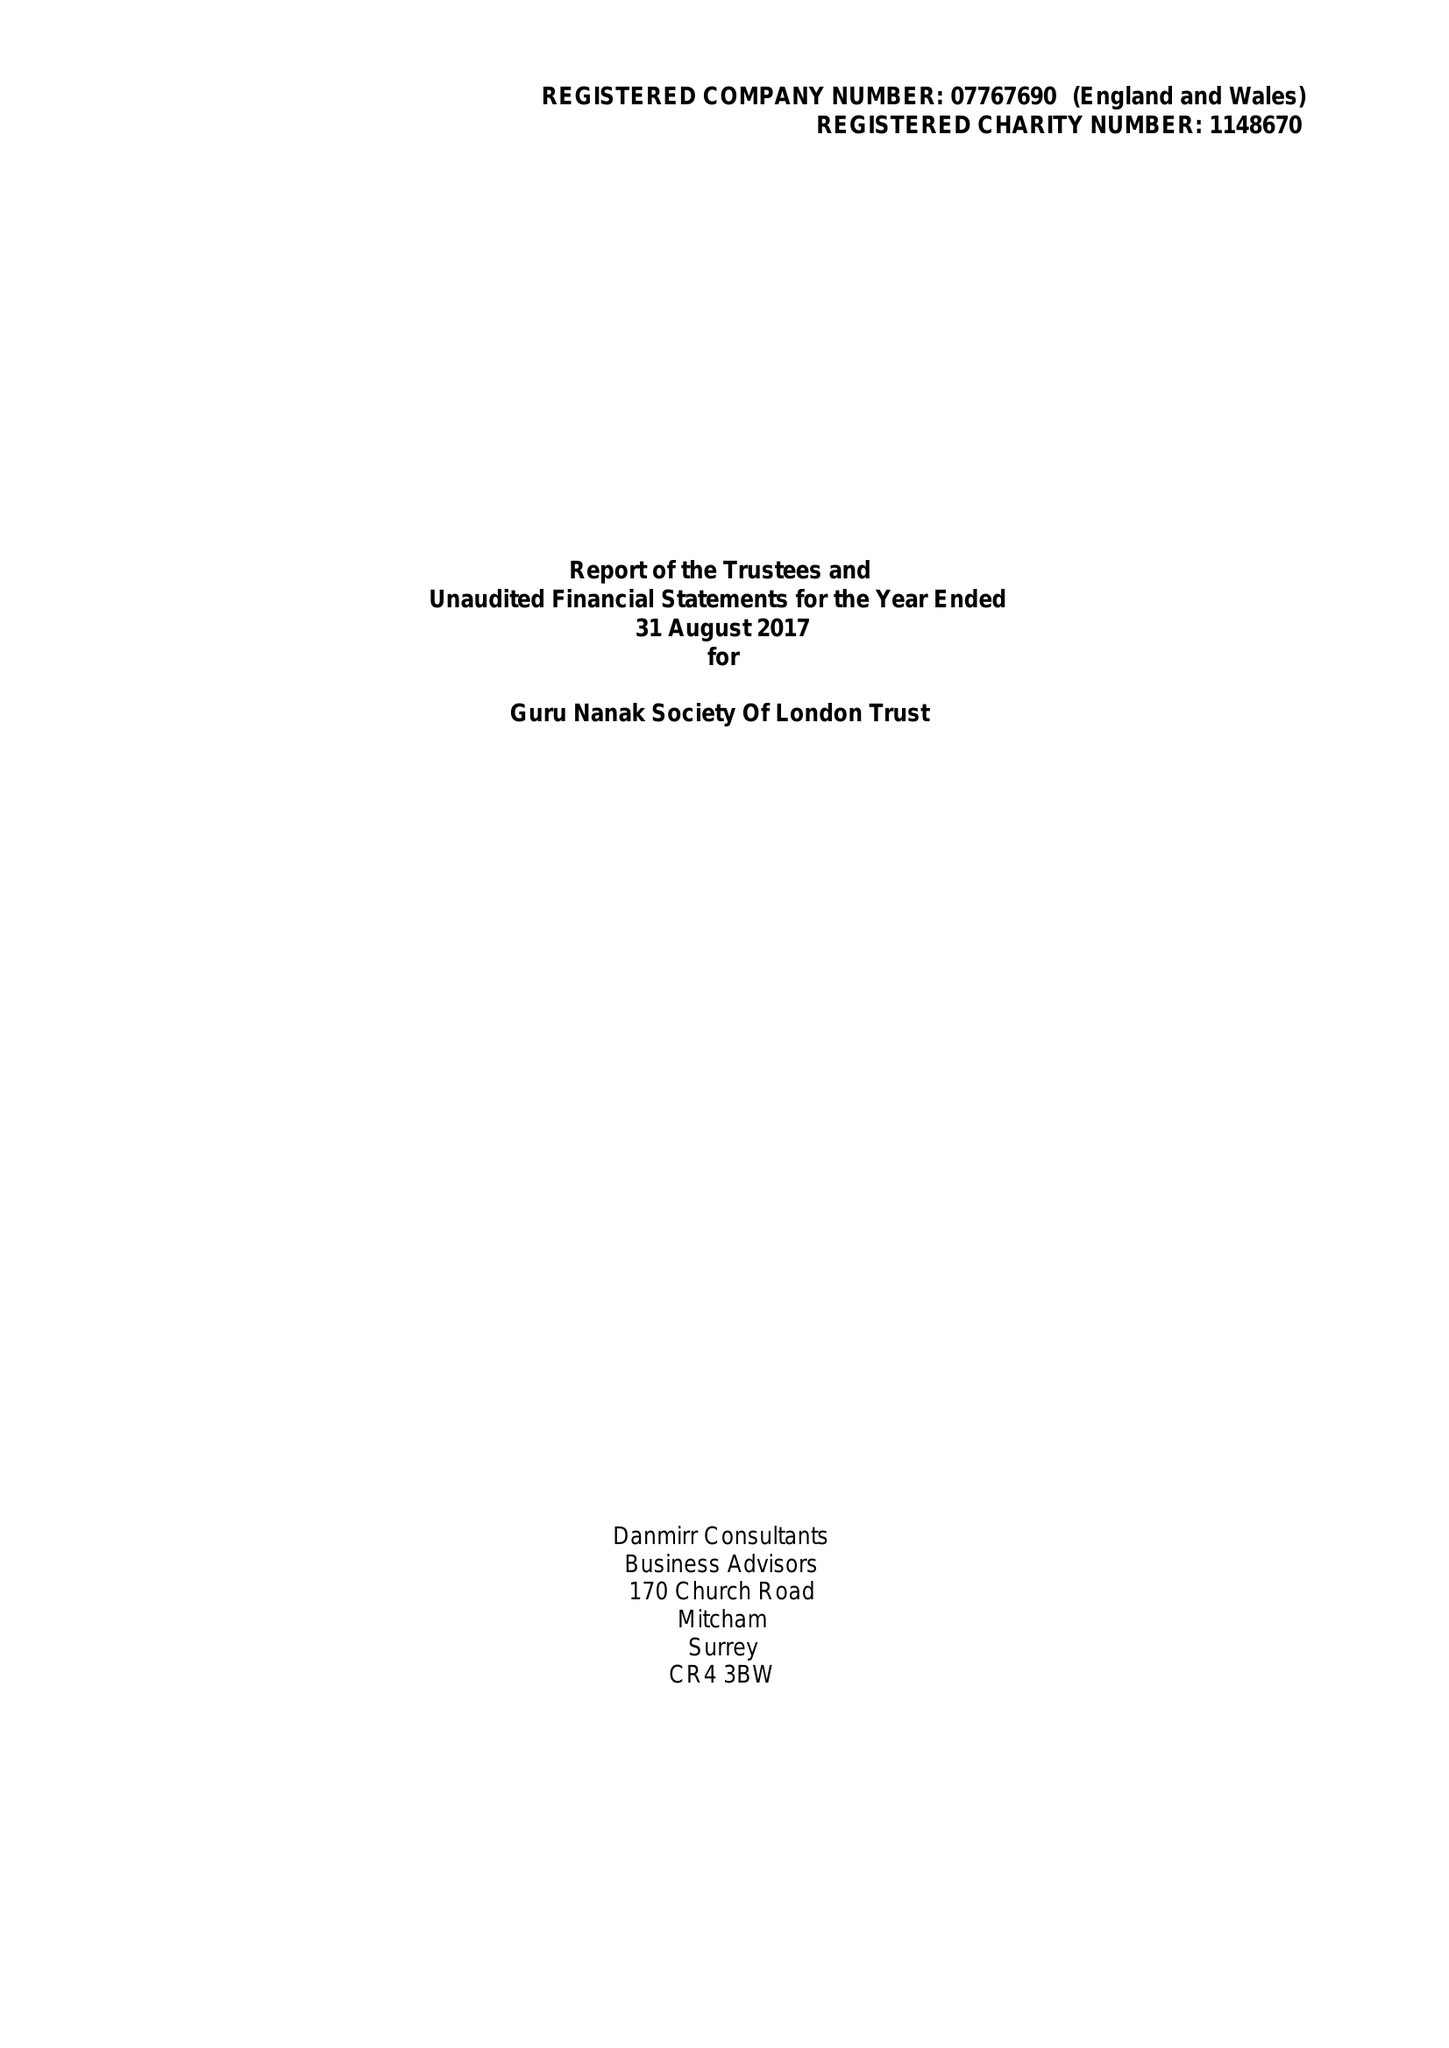What is the value for the address__post_town?
Answer the question using a single word or phrase. SOUTHALL 